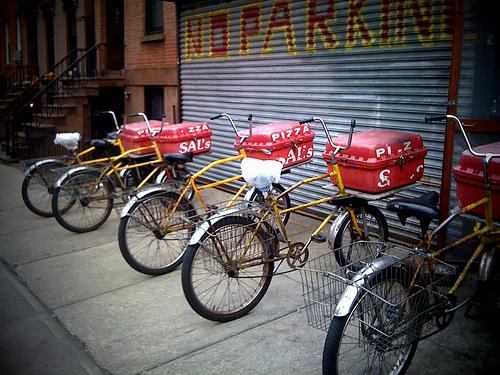What type of surface is on the ground?
Short answer required. Concrete. What is the red thing on the back of the bike?
Keep it brief. Pizza box. Do these bikes match?
Answer briefly. Yes. How many bikes are here?
Quick response, please. 5. What does the garage door say?
Be succinct. No parking. How many bikes can be seen?
Short answer required. 5. Who owns the pizza business?
Answer briefly. Sal. How many bikes are there?
Answer briefly. 5. 